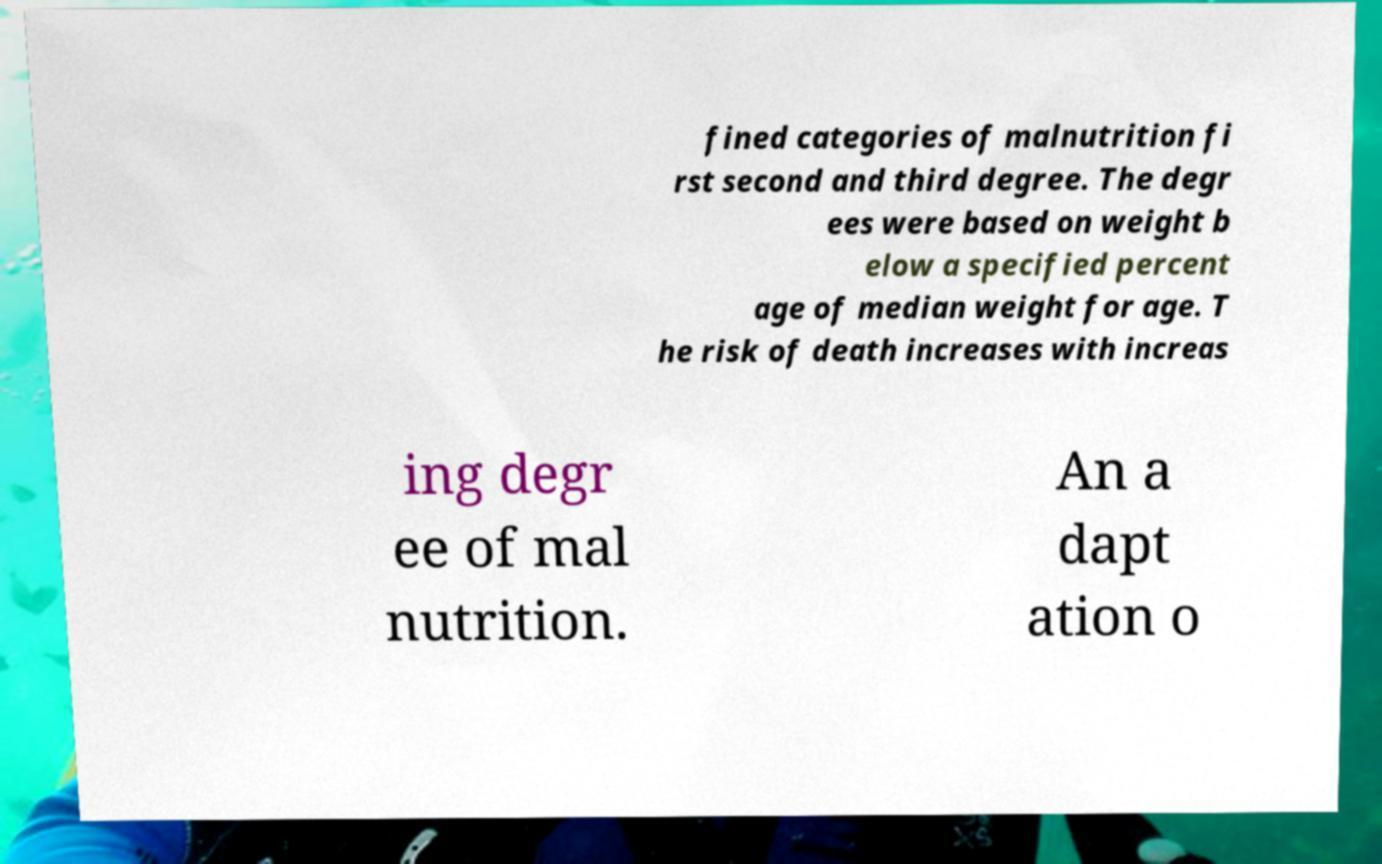Could you assist in decoding the text presented in this image and type it out clearly? fined categories of malnutrition fi rst second and third degree. The degr ees were based on weight b elow a specified percent age of median weight for age. T he risk of death increases with increas ing degr ee of mal nutrition. An a dapt ation o 